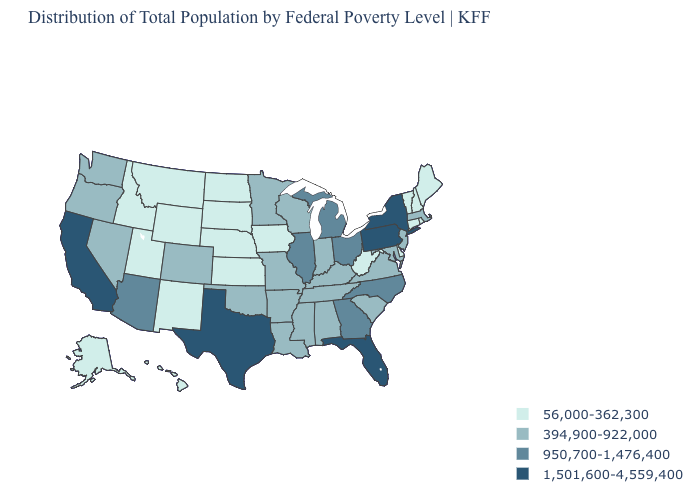Does Tennessee have the same value as Kansas?
Concise answer only. No. Is the legend a continuous bar?
Be succinct. No. What is the value of New Jersey?
Short answer required. 394,900-922,000. What is the highest value in states that border Oregon?
Write a very short answer. 1,501,600-4,559,400. Does the map have missing data?
Write a very short answer. No. What is the value of Missouri?
Answer briefly. 394,900-922,000. What is the value of Oklahoma?
Answer briefly. 394,900-922,000. Name the states that have a value in the range 1,501,600-4,559,400?
Write a very short answer. California, Florida, New York, Pennsylvania, Texas. How many symbols are there in the legend?
Keep it brief. 4. Which states have the highest value in the USA?
Keep it brief. California, Florida, New York, Pennsylvania, Texas. Is the legend a continuous bar?
Short answer required. No. What is the value of Wyoming?
Short answer required. 56,000-362,300. What is the value of Georgia?
Quick response, please. 950,700-1,476,400. What is the lowest value in the MidWest?
Short answer required. 56,000-362,300. Name the states that have a value in the range 56,000-362,300?
Give a very brief answer. Alaska, Connecticut, Delaware, Hawaii, Idaho, Iowa, Kansas, Maine, Montana, Nebraska, New Hampshire, New Mexico, North Dakota, Rhode Island, South Dakota, Utah, Vermont, West Virginia, Wyoming. 